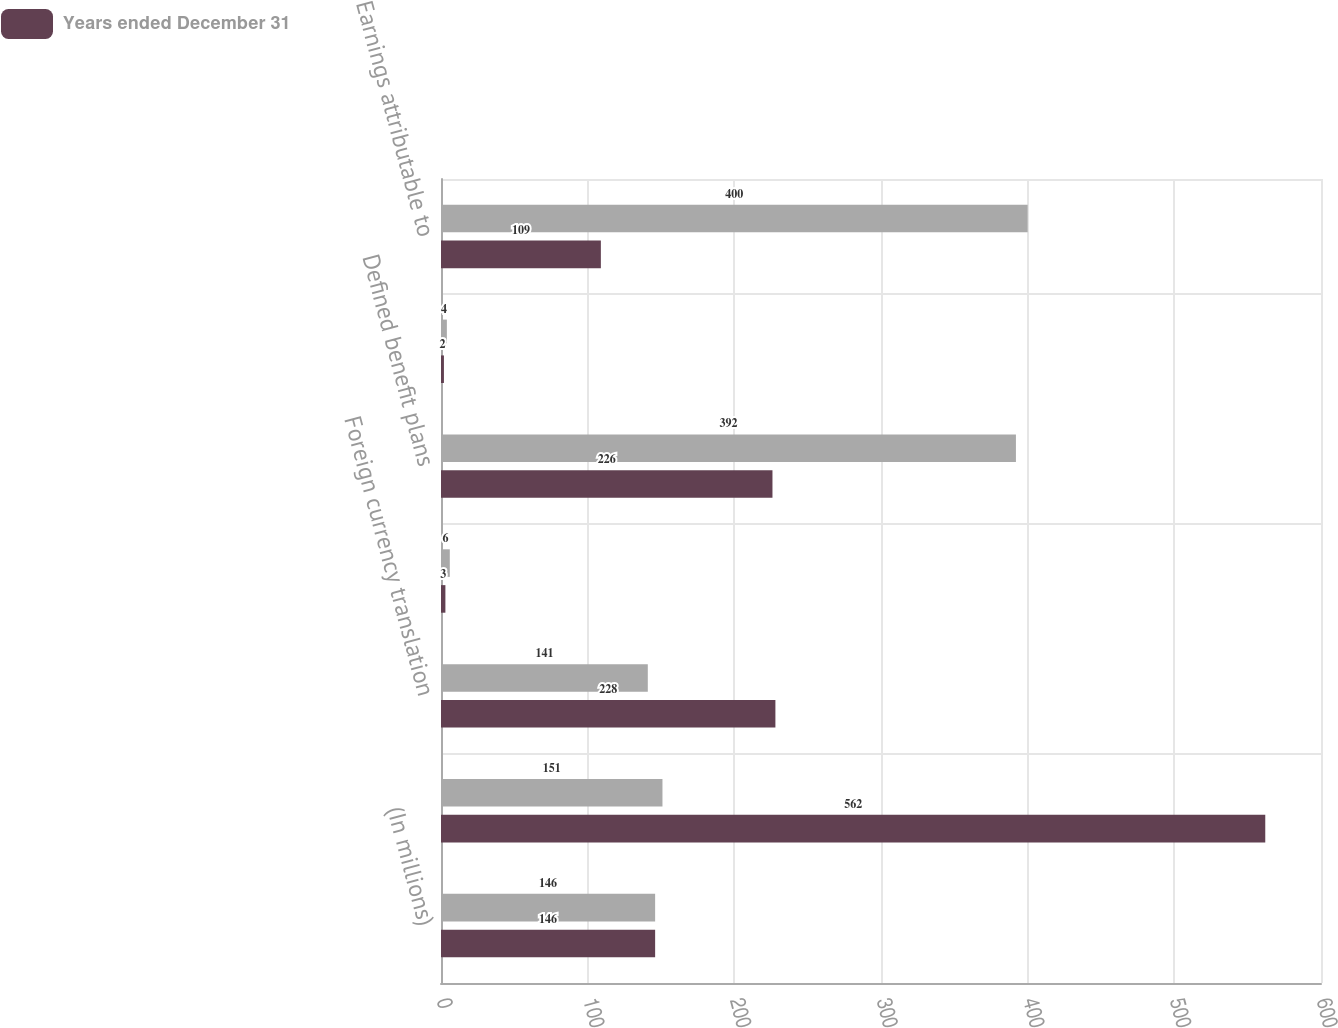Convert chart. <chart><loc_0><loc_0><loc_500><loc_500><stacked_bar_chart><ecel><fcel>(In millions)<fcel>Net earnings (loss)<fcel>Foreign currency translation<fcel>Marketable securities<fcel>Defined benefit plans<fcel>Comprehensive income (loss)<fcel>Less Earnings attributable to<nl><fcel>nan<fcel>146<fcel>151<fcel>141<fcel>6<fcel>392<fcel>4<fcel>400<nl><fcel>Years ended December 31<fcel>146<fcel>562<fcel>228<fcel>3<fcel>226<fcel>2<fcel>109<nl></chart> 